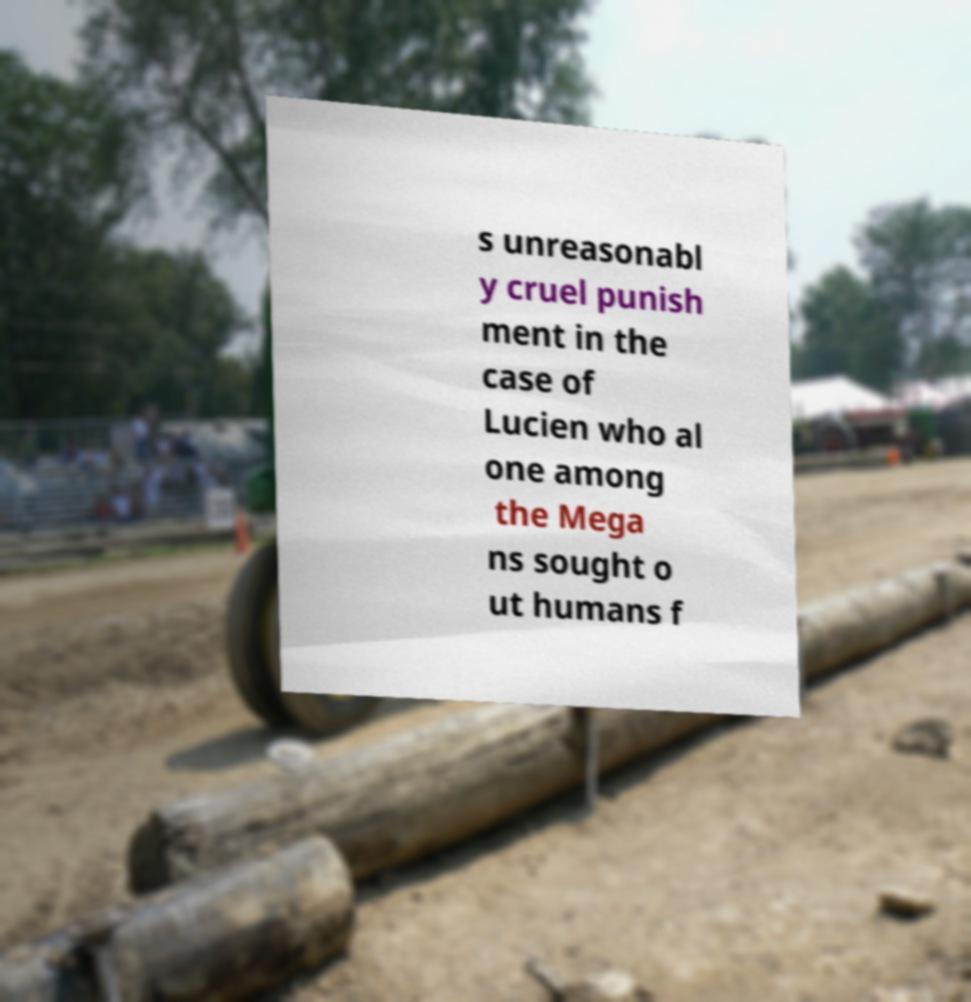For documentation purposes, I need the text within this image transcribed. Could you provide that? s unreasonabl y cruel punish ment in the case of Lucien who al one among the Mega ns sought o ut humans f 